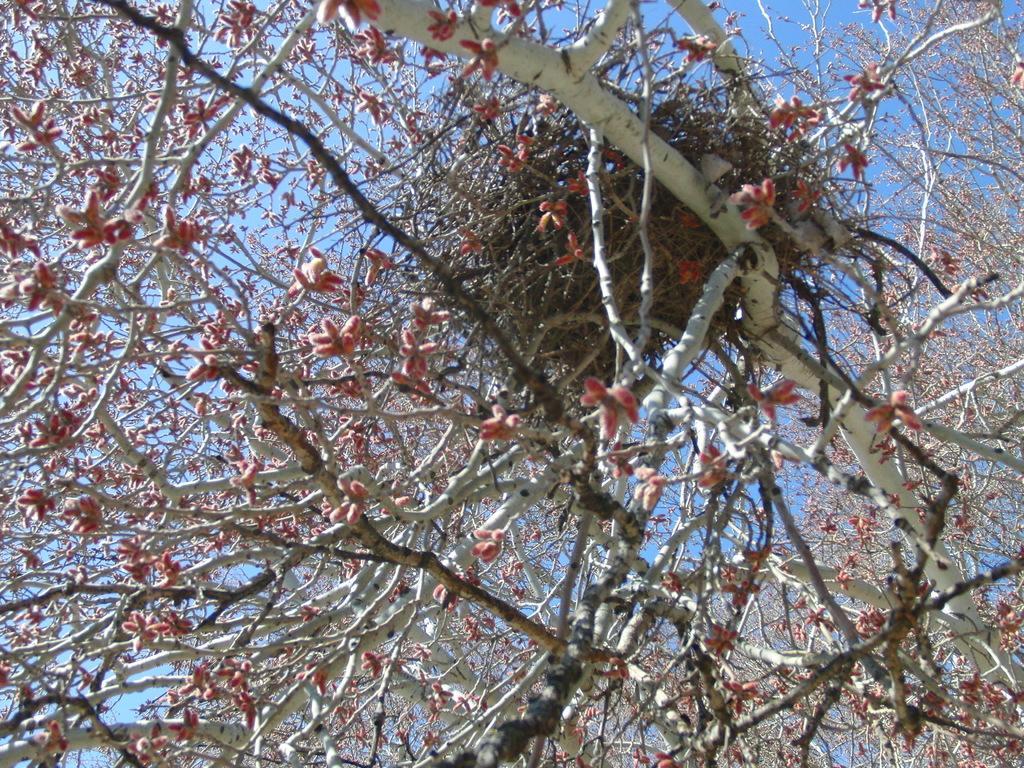Please provide a concise description of this image. In this picture we can see trees. In the back we can see a sky. 